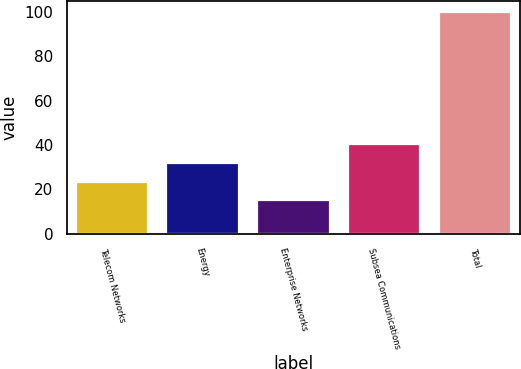<chart> <loc_0><loc_0><loc_500><loc_500><bar_chart><fcel>Telecom Networks<fcel>Energy<fcel>Enterprise Networks<fcel>Subsea Communications<fcel>Total<nl><fcel>23.5<fcel>32<fcel>15<fcel>40.5<fcel>100<nl></chart> 